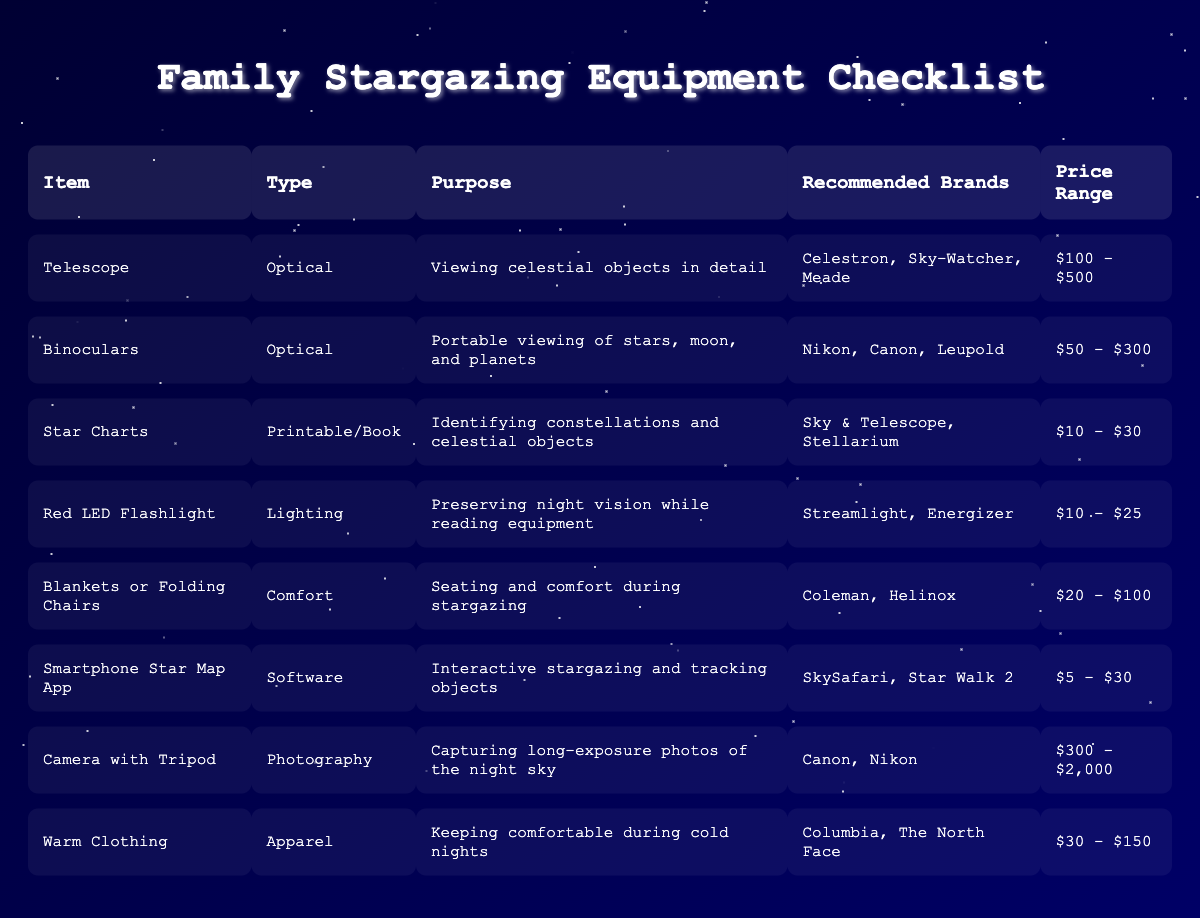What is the price range for a telescope? The price range for a telescope is listed in the table under the "Price Range" column for the "Telescope" item. It shows "$100 - $500."
Answer: $100 - $500 Which item has the highest price range? The highest price range can be determined by comparing the price ranges of all the items in the table. The "Camera with Tripod" has a price range of "$300 - $2,000," which is the highest among all items listed.
Answer: Camera with Tripod Is a red LED flashlight considered an optical equipment? To answer this, we look at the "Type" column for the "Red LED Flashlight." It is categorized as "Lighting," which means it does not fall under optical equipment.
Answer: No How many items recommended are priced under $50? We need to check the "Price Range" of each item listed in the table. Only the "Smartphone Star Map App" with a price range of "$5 - $30," and "Star Charts" with a price range of "$10 - $30" are below $50; thus, there are two items.
Answer: 2 What is the average price range of optical equipment? First, we need to identify the optical equipment: Telescope ($100 - $500), Binoculars ($50 - $300). To find an average, we take the midpoints: (100 + 500)/2 = 300 for the telescope, and (50 + 300)/2 = 175 for binoculars. Then, the average is (300 + 175)/2 = 237.5.
Answer: $237.5 What brands are recommended for binoculars? The "Recommended Brands" column for "Binoculars" lists "Nikon, Canon, Leupold."
Answer: Nikon, Canon, Leupold Is it true that warm clothing helps in keeping comfortable during cold nights? Referring to the "Purpose" of the item "Warm Clothing," it explicitly states "Keeping comfortable during cold nights," confirming the truth of the statement.
Answer: Yes What is the purpose of star charts according to the table? The purpose of "Star Charts" is specified in the "Purpose" column, which states it is for "Identifying constellations and celestial objects."
Answer: Identifying constellations and celestial objects 